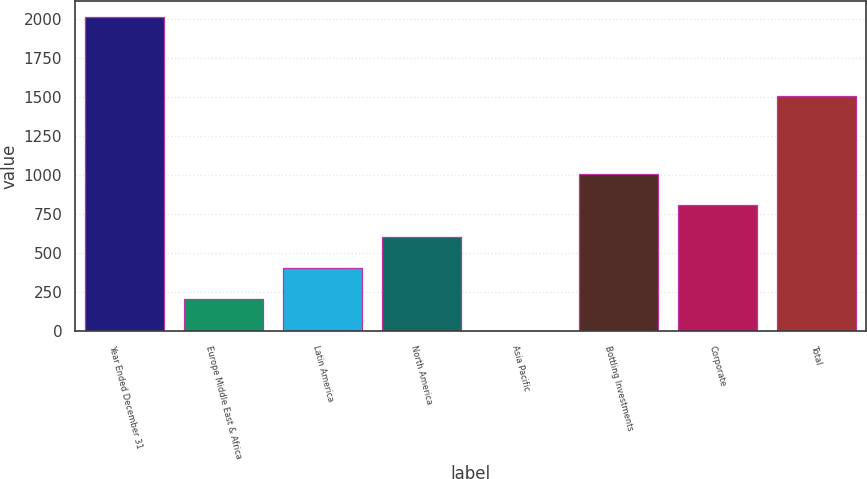Convert chart. <chart><loc_0><loc_0><loc_500><loc_500><bar_chart><fcel>Year Ended December 31<fcel>Europe Middle East & Africa<fcel>Latin America<fcel>North America<fcel>Asia Pacific<fcel>Bottling Investments<fcel>Corporate<fcel>Total<nl><fcel>2016<fcel>202.5<fcel>404<fcel>605.5<fcel>1<fcel>1008.5<fcel>807<fcel>1510<nl></chart> 